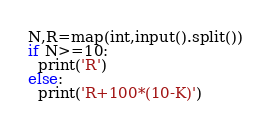<code> <loc_0><loc_0><loc_500><loc_500><_Python_>N,R=map(int,input().split())
if N>=10:
  print('R')
else:
  print('R+100*(10-K)')
        </code> 